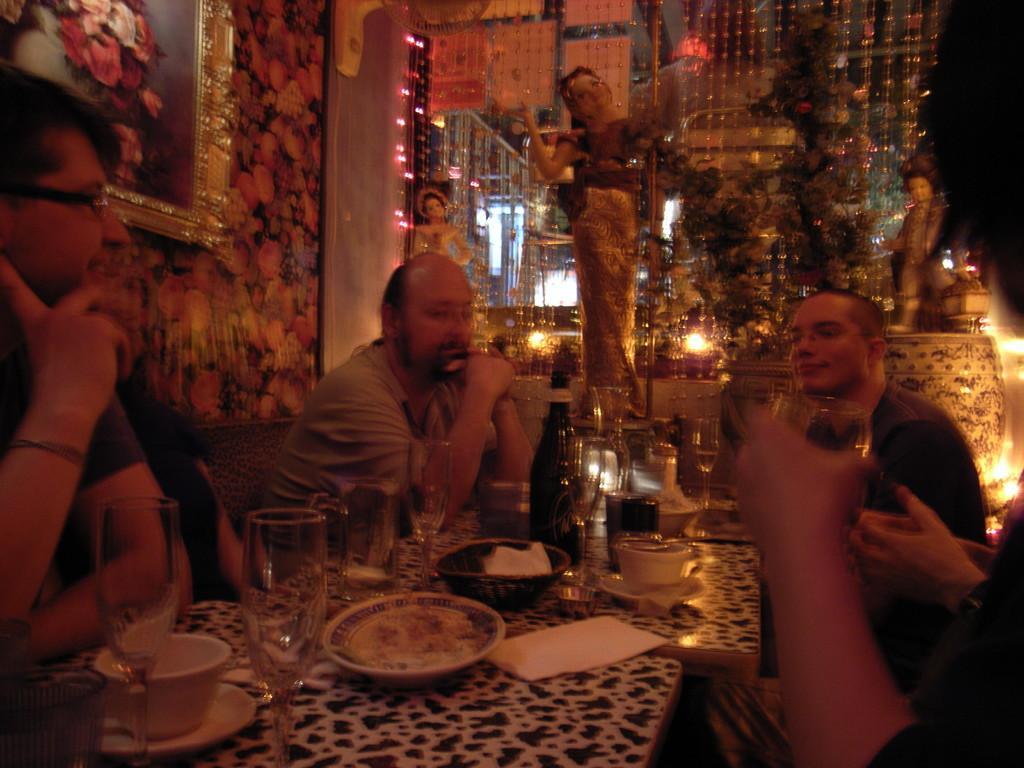Please provide a concise description of this image. In this image we can see a few people sitting on the chairs, in front of them there are some tables, on the tables we can see some plates, cups, glasses, paper and other objects, there are some trees, statues, lights and a photo frame. 